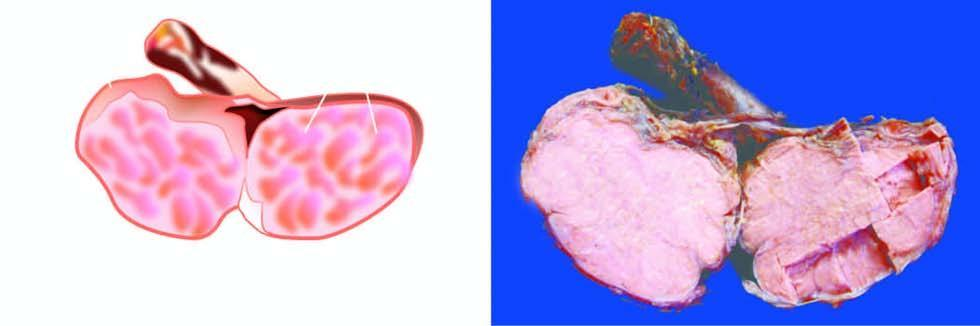how is the testis enlarged?
Answer the question using a single word or phrase. Without distorting its contour 